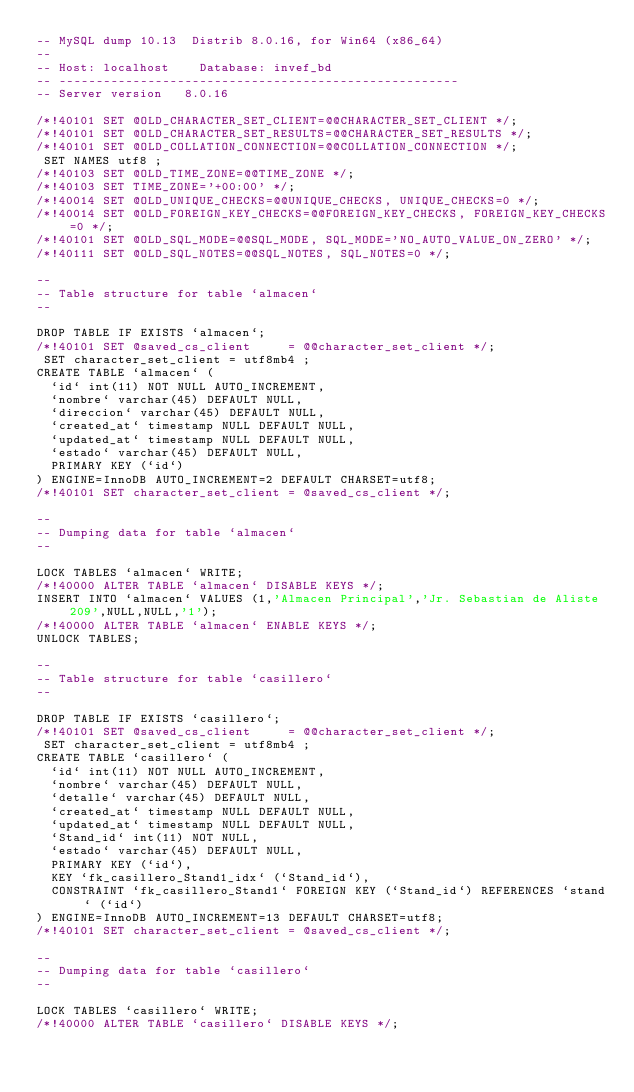Convert code to text. <code><loc_0><loc_0><loc_500><loc_500><_SQL_>-- MySQL dump 10.13  Distrib 8.0.16, for Win64 (x86_64)
--
-- Host: localhost    Database: invef_bd
-- ------------------------------------------------------
-- Server version	8.0.16

/*!40101 SET @OLD_CHARACTER_SET_CLIENT=@@CHARACTER_SET_CLIENT */;
/*!40101 SET @OLD_CHARACTER_SET_RESULTS=@@CHARACTER_SET_RESULTS */;
/*!40101 SET @OLD_COLLATION_CONNECTION=@@COLLATION_CONNECTION */;
 SET NAMES utf8 ;
/*!40103 SET @OLD_TIME_ZONE=@@TIME_ZONE */;
/*!40103 SET TIME_ZONE='+00:00' */;
/*!40014 SET @OLD_UNIQUE_CHECKS=@@UNIQUE_CHECKS, UNIQUE_CHECKS=0 */;
/*!40014 SET @OLD_FOREIGN_KEY_CHECKS=@@FOREIGN_KEY_CHECKS, FOREIGN_KEY_CHECKS=0 */;
/*!40101 SET @OLD_SQL_MODE=@@SQL_MODE, SQL_MODE='NO_AUTO_VALUE_ON_ZERO' */;
/*!40111 SET @OLD_SQL_NOTES=@@SQL_NOTES, SQL_NOTES=0 */;

--
-- Table structure for table `almacen`
--

DROP TABLE IF EXISTS `almacen`;
/*!40101 SET @saved_cs_client     = @@character_set_client */;
 SET character_set_client = utf8mb4 ;
CREATE TABLE `almacen` (
  `id` int(11) NOT NULL AUTO_INCREMENT,
  `nombre` varchar(45) DEFAULT NULL,
  `direccion` varchar(45) DEFAULT NULL,
  `created_at` timestamp NULL DEFAULT NULL,
  `updated_at` timestamp NULL DEFAULT NULL,
  `estado` varchar(45) DEFAULT NULL,
  PRIMARY KEY (`id`)
) ENGINE=InnoDB AUTO_INCREMENT=2 DEFAULT CHARSET=utf8;
/*!40101 SET character_set_client = @saved_cs_client */;

--
-- Dumping data for table `almacen`
--

LOCK TABLES `almacen` WRITE;
/*!40000 ALTER TABLE `almacen` DISABLE KEYS */;
INSERT INTO `almacen` VALUES (1,'Almacen Principal','Jr. Sebastian de Aliste 209',NULL,NULL,'1');
/*!40000 ALTER TABLE `almacen` ENABLE KEYS */;
UNLOCK TABLES;

--
-- Table structure for table `casillero`
--

DROP TABLE IF EXISTS `casillero`;
/*!40101 SET @saved_cs_client     = @@character_set_client */;
 SET character_set_client = utf8mb4 ;
CREATE TABLE `casillero` (
  `id` int(11) NOT NULL AUTO_INCREMENT,
  `nombre` varchar(45) DEFAULT NULL,
  `detalle` varchar(45) DEFAULT NULL,
  `created_at` timestamp NULL DEFAULT NULL,
  `updated_at` timestamp NULL DEFAULT NULL,
  `Stand_id` int(11) NOT NULL,
  `estado` varchar(45) DEFAULT NULL,
  PRIMARY KEY (`id`),
  KEY `fk_casillero_Stand1_idx` (`Stand_id`),
  CONSTRAINT `fk_casillero_Stand1` FOREIGN KEY (`Stand_id`) REFERENCES `stand` (`id`)
) ENGINE=InnoDB AUTO_INCREMENT=13 DEFAULT CHARSET=utf8;
/*!40101 SET character_set_client = @saved_cs_client */;

--
-- Dumping data for table `casillero`
--

LOCK TABLES `casillero` WRITE;
/*!40000 ALTER TABLE `casillero` DISABLE KEYS */;</code> 